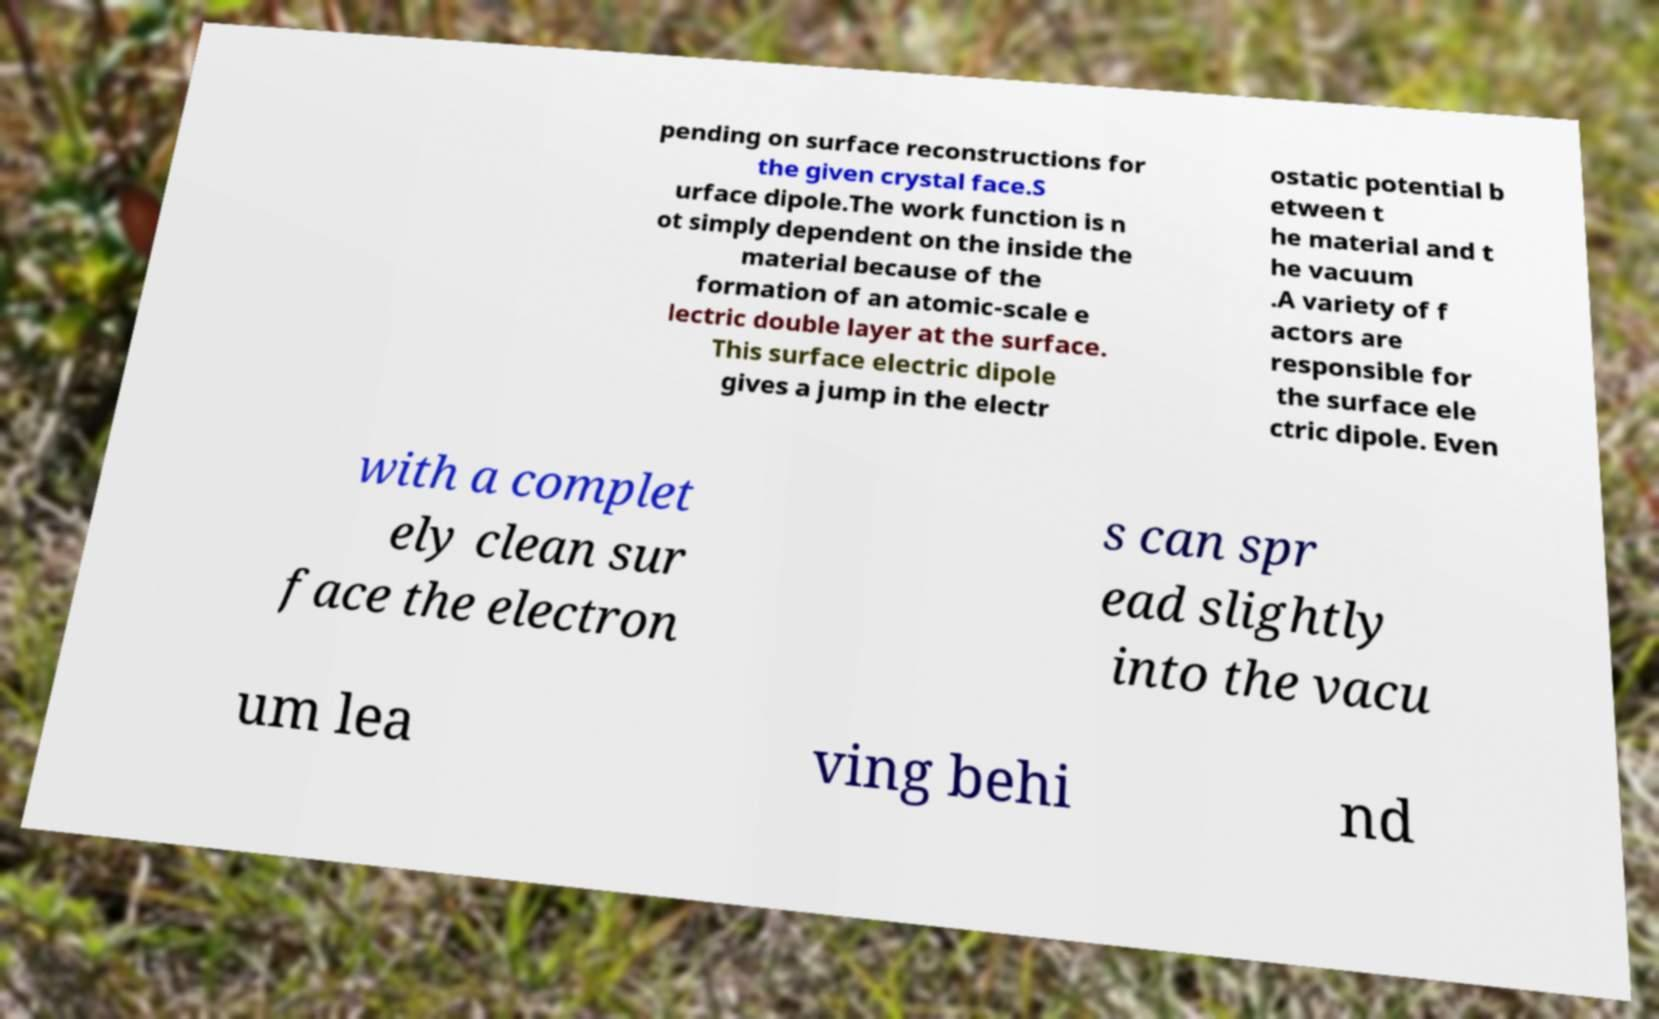Can you read and provide the text displayed in the image?This photo seems to have some interesting text. Can you extract and type it out for me? pending on surface reconstructions for the given crystal face.S urface dipole.The work function is n ot simply dependent on the inside the material because of the formation of an atomic-scale e lectric double layer at the surface. This surface electric dipole gives a jump in the electr ostatic potential b etween t he material and t he vacuum .A variety of f actors are responsible for the surface ele ctric dipole. Even with a complet ely clean sur face the electron s can spr ead slightly into the vacu um lea ving behi nd 